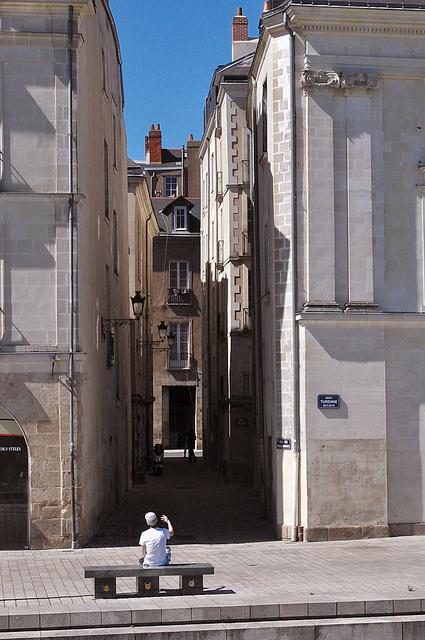Is there a clock?
Be succinct. No. What color is the shirt of the man?
Keep it brief. White. Is the boy skinny?
Be succinct. Yes. How tall is the building on the right?
Be succinct. Roughly 100 feet. What color is the sky?
Quick response, please. Blue. 